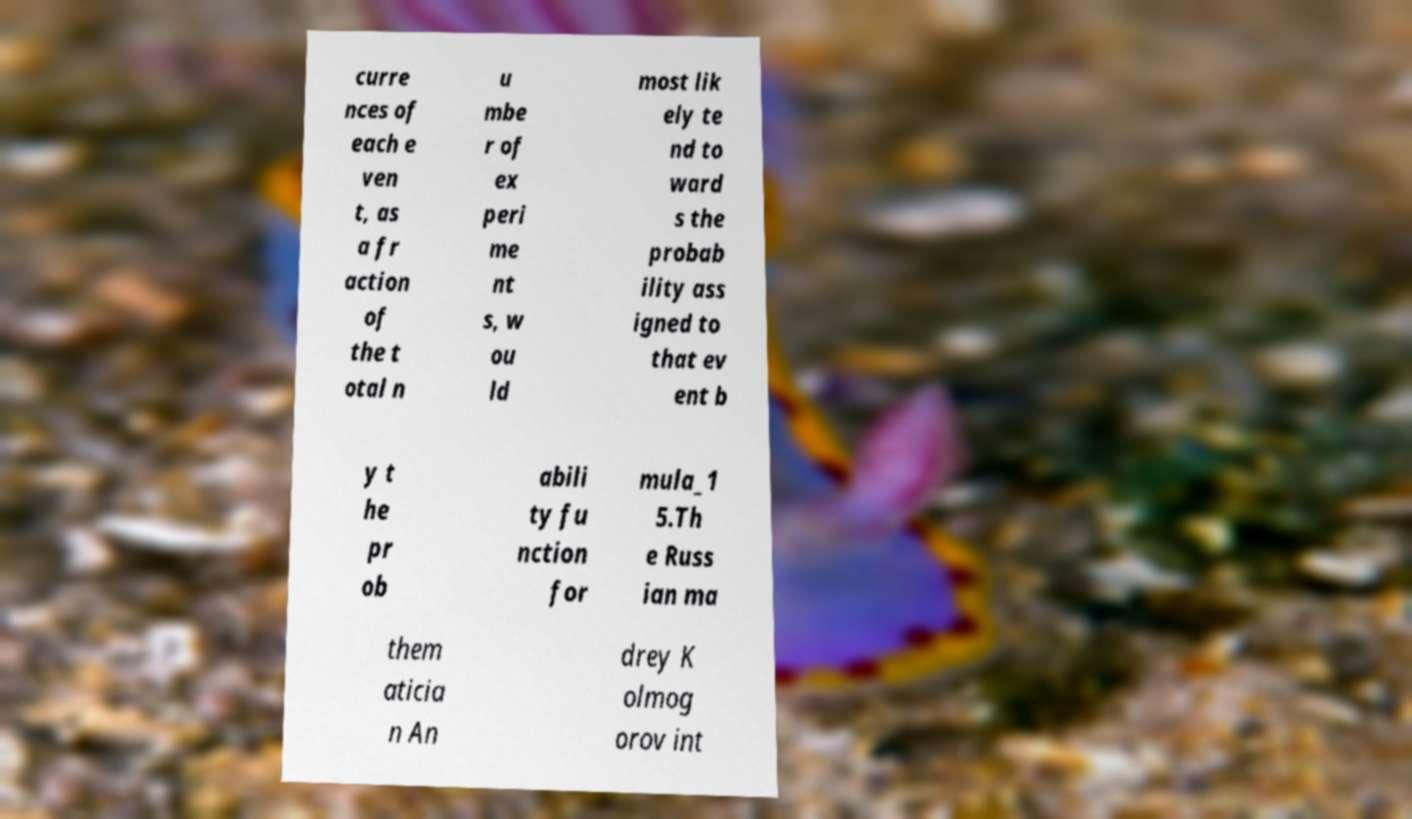Could you assist in decoding the text presented in this image and type it out clearly? curre nces of each e ven t, as a fr action of the t otal n u mbe r of ex peri me nt s, w ou ld most lik ely te nd to ward s the probab ility ass igned to that ev ent b y t he pr ob abili ty fu nction for mula_1 5.Th e Russ ian ma them aticia n An drey K olmog orov int 